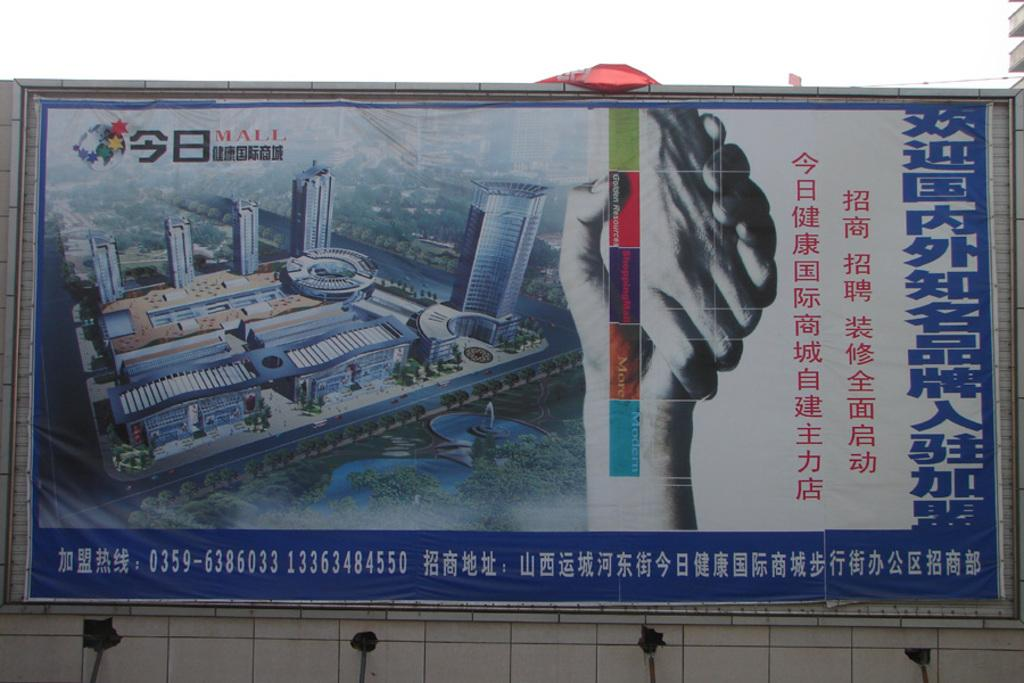What is the main subject in the image? There is a hoarding in the image. What can be seen in the background of the image? The sky is visible at the top of the image. What type of polish is being applied to the hoarding in the image? There is no polish or any indication of a polishing operation in the image; it only features a hoarding and the sky. 